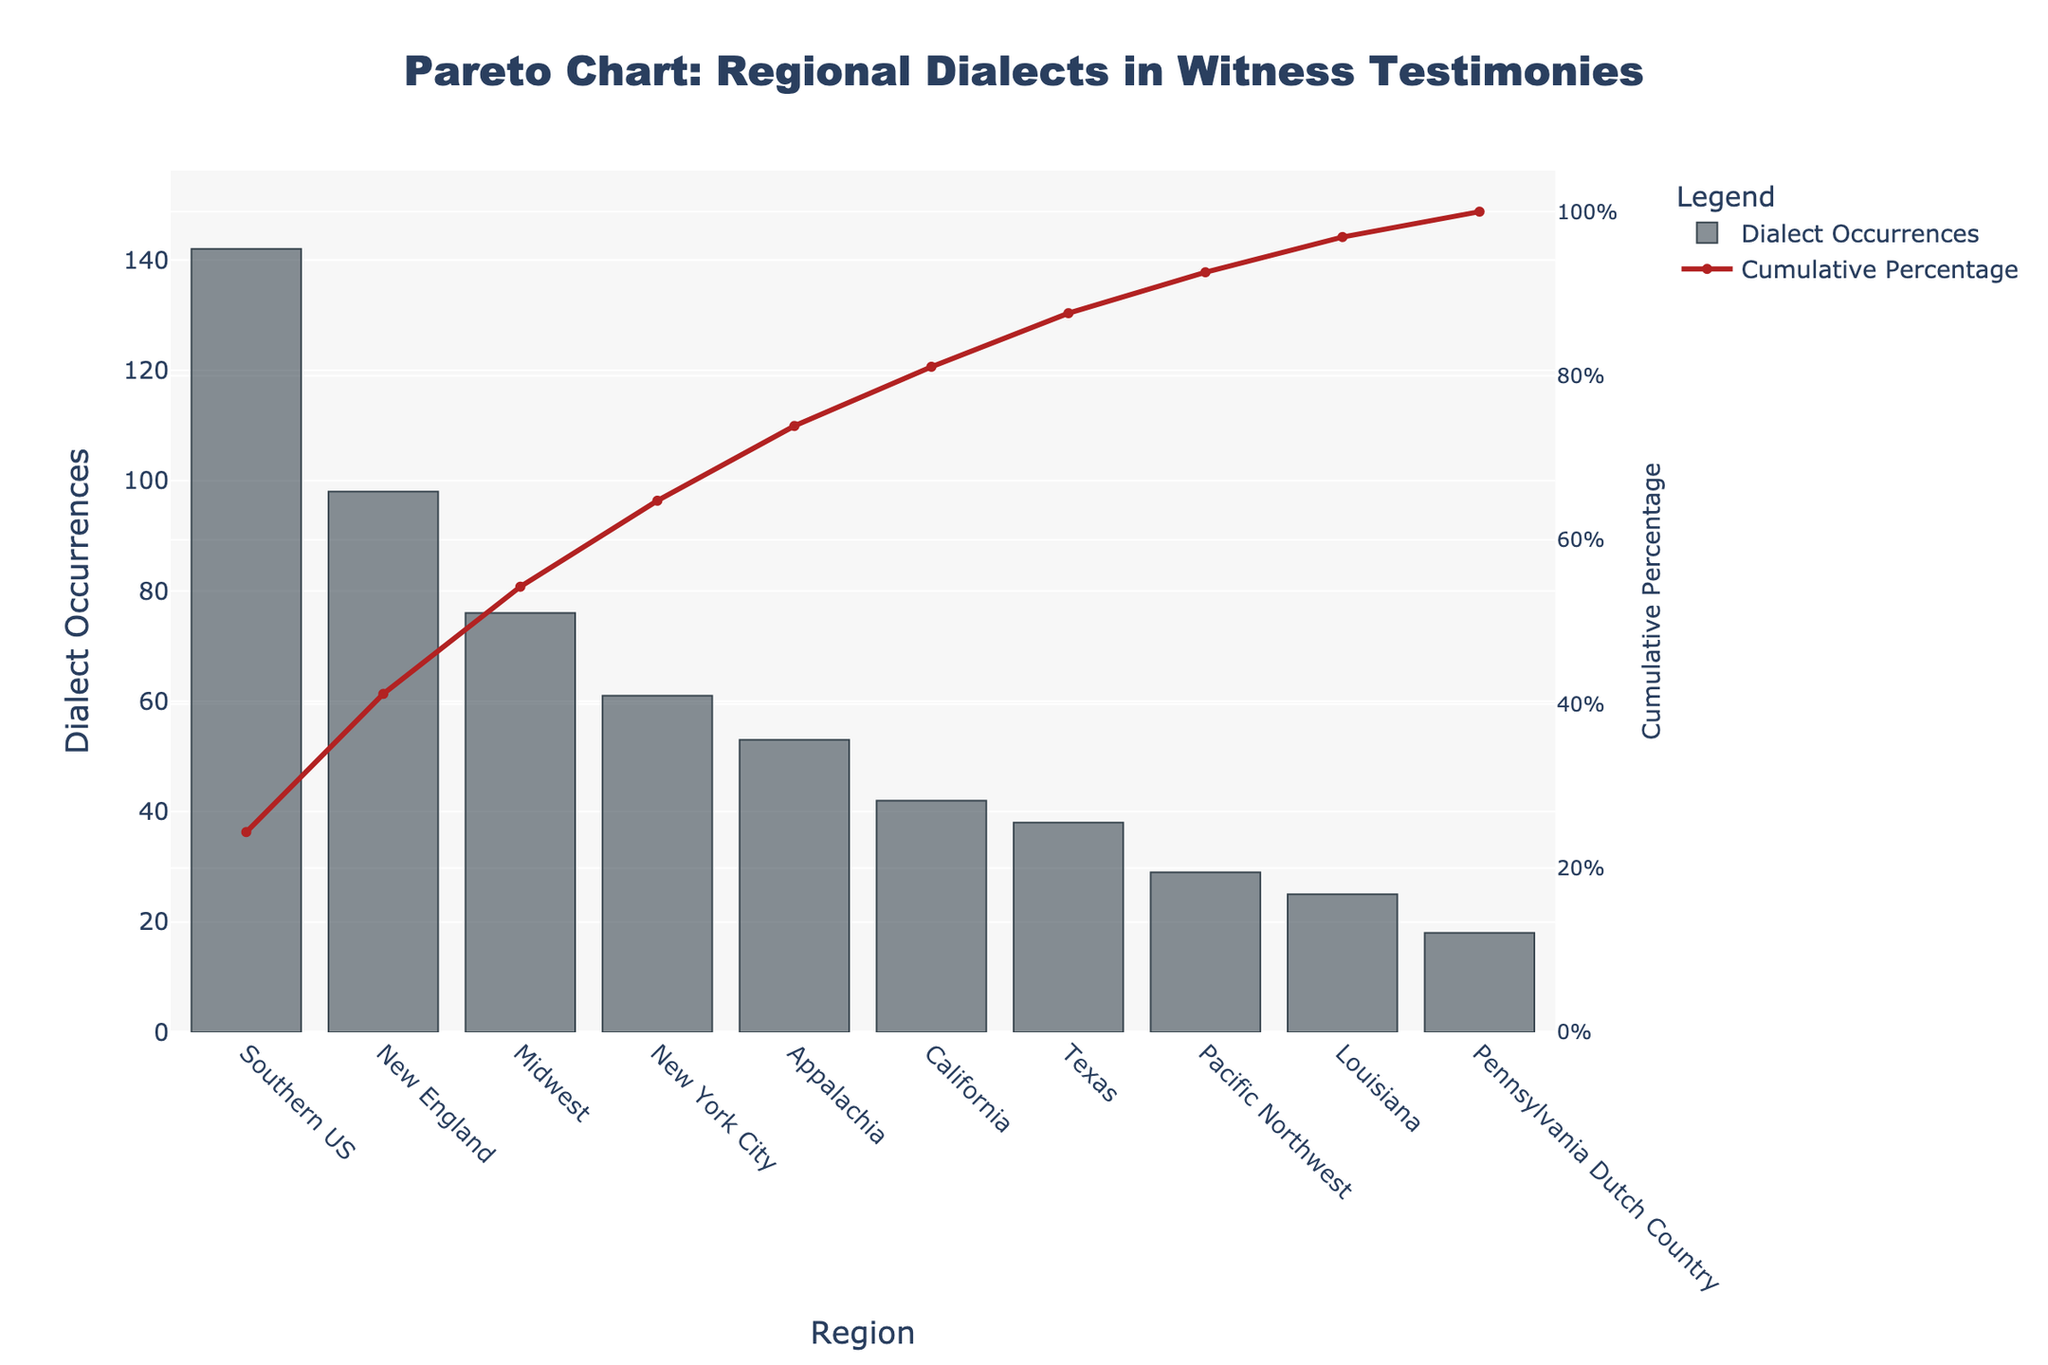What's the title of the figure? The title is located at the top center of the figure and can be read directly.
Answer: Pareto Chart: Regional Dialects in Witness Testimonies Which region has the highest number of dialect occurrences? The region with the highest number of occurrences is at the far left of the bar chart.
Answer: Southern US What percentage of total dialect occurrences is contributed by the Southern US region? Check the cumulative percentage line corresponding to the Southern US bar.
Answer: 24.80% What regions contribute to the top 50% of dialect occurrences cumulatively? Calculate the cumulative percentage until you reach or exceed 50%. The regions in order are Southern US, New England, and Midwest.
Answer: Southern US, New England, Midwest How does the number of dialect occurrences in the Midwest compare to New York City? Compare the heights of the bars for Midwest and New York City.
Answer: Midwest has more occurrences than New York City What is the cumulative percentage after adding Appalachia's occurrences? Sum the cumulative percentages up to and including Appalachia. The value after New York City is 74.80%, adding Appalachia gives 83.07%.
Answer: 83.07% How many regions have fewer than 40 dialect occurrences? Count the bars with values less than 40 from the Pareto chart. There are 4: Texas, Pacific Northwest, Louisiana, Pennsylvania Dutch Country.
Answer: Four Which region has the lowest number of dialect occurrences? The region with the shortest bar on the chart.
Answer: Pennsylvania Dutch Country By how much does the number of dialect occurrences in New England exceed that in Texas? Subtract the number of occurrences in Texas from the number in New England: 98 - 38.
Answer: 60 What cumulative percentage does California contribute to? Find the cumulative percentage on the line chart corresponding to the California bar.
Answer: 88.56% 